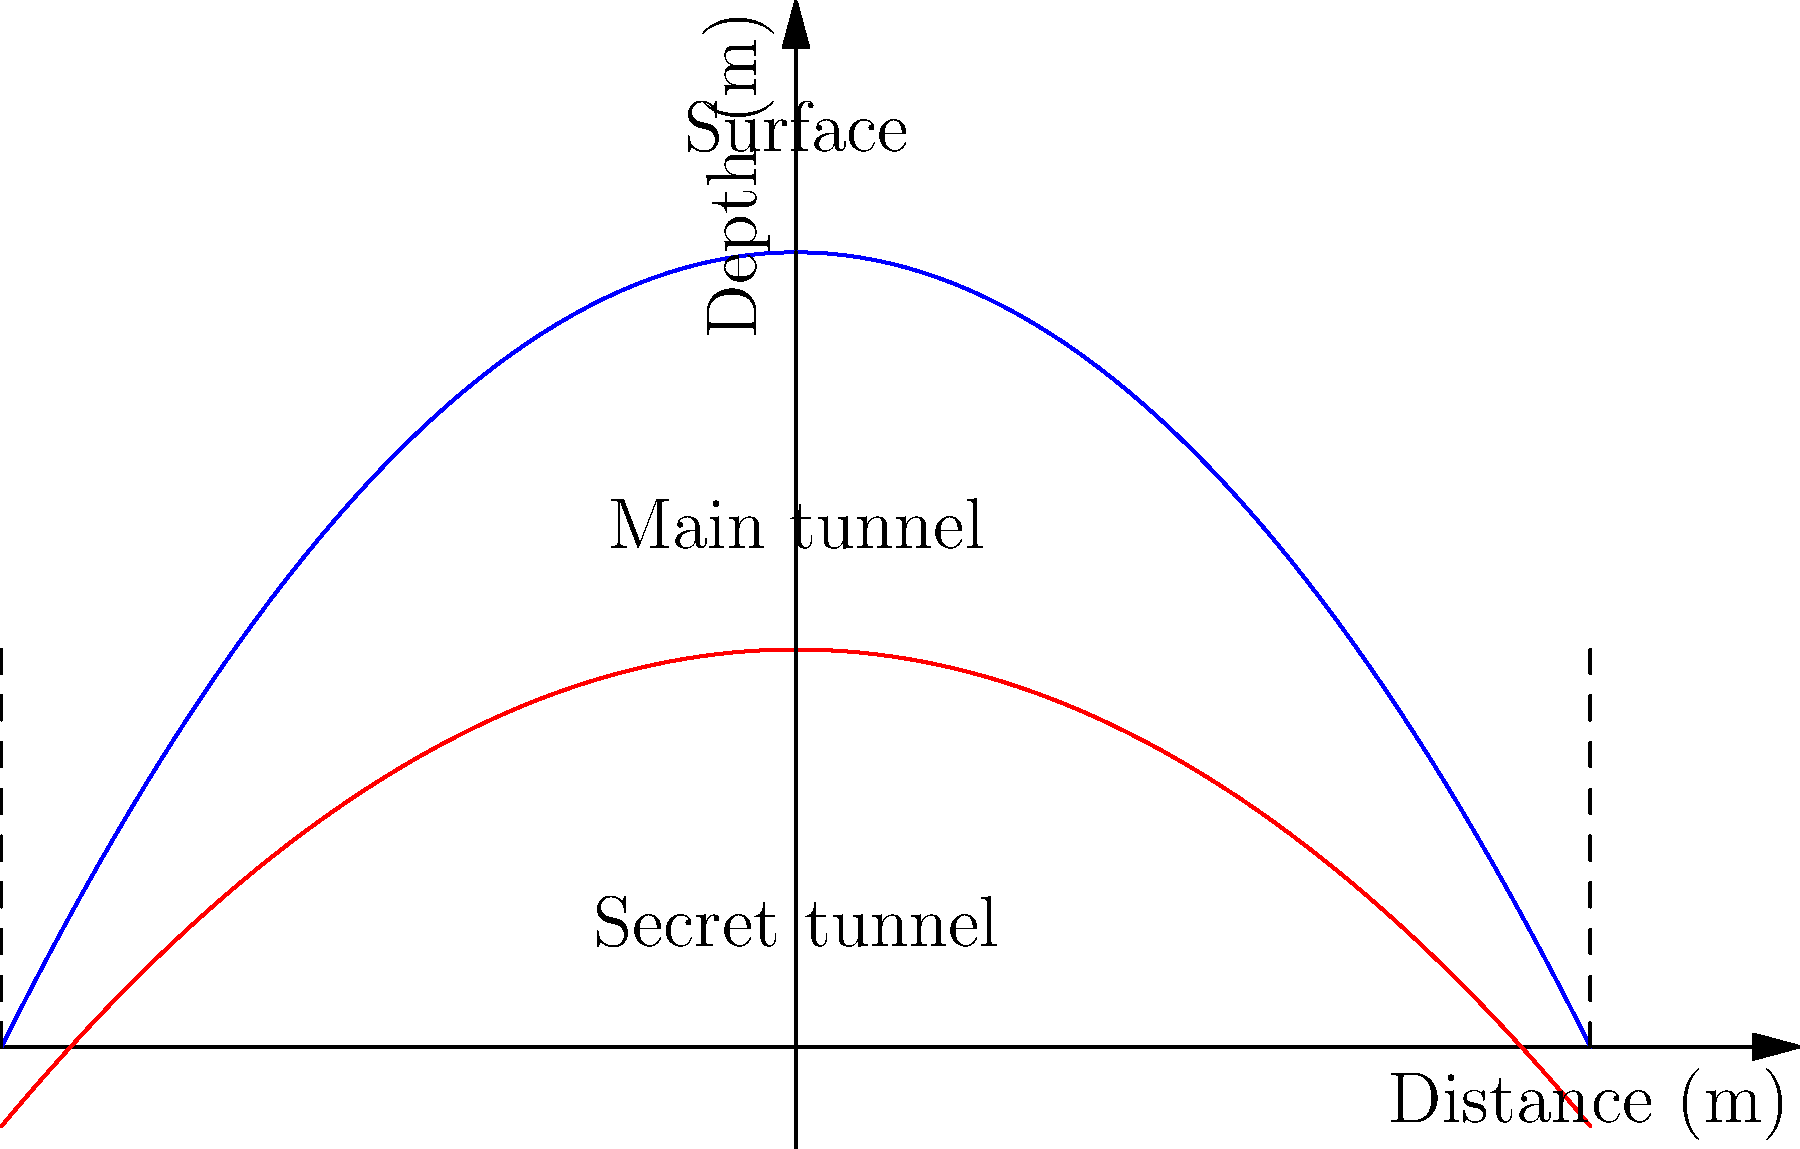According to the cross-sectional diagram of alleged underground tunnels beneath a major city, what is the approximate maximum depth difference between the main tunnel and the secret tunnel at the center point? To find the depth difference between the main tunnel and the secret tunnel at the center point, we need to follow these steps:

1. Identify the center point on the x-axis (0 m).
2. Determine the depth of the main tunnel at x = 0 m:
   The blue curve represents the main tunnel, which reaches its maximum at x = 0.
   From the graph, we can estimate this depth to be approximately 20 m.
3. Determine the depth of the secret tunnel at x = 0 m:
   The red curve represents the secret tunnel, which also reaches its maximum at x = 0.
   From the graph, we can estimate this depth to be approximately 10 m.
4. Calculate the difference:
   Depth difference = Main tunnel depth - Secret tunnel depth
   $$ 20 \text{ m} - 10 \text{ m} = 10 \text{ m} $$

Therefore, the approximate maximum depth difference between the main tunnel and the secret tunnel at the center point is 10 meters.
Answer: 10 meters 